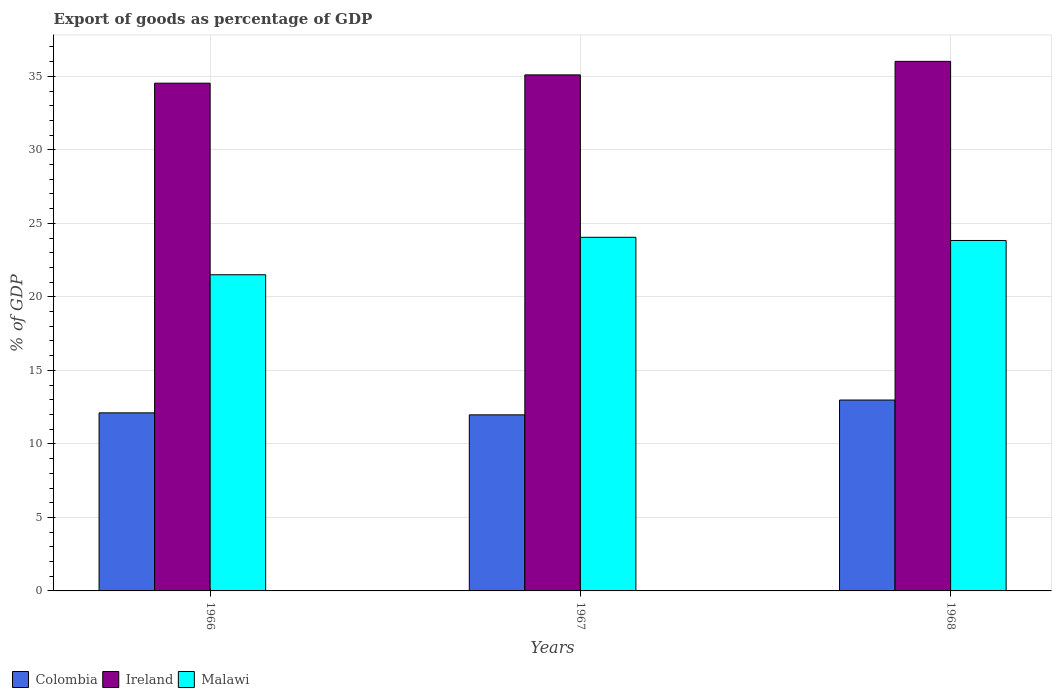How many groups of bars are there?
Offer a very short reply. 3. What is the label of the 1st group of bars from the left?
Give a very brief answer. 1966. In how many cases, is the number of bars for a given year not equal to the number of legend labels?
Offer a very short reply. 0. What is the export of goods as percentage of GDP in Ireland in 1967?
Your response must be concise. 35.1. Across all years, what is the maximum export of goods as percentage of GDP in Colombia?
Make the answer very short. 12.98. Across all years, what is the minimum export of goods as percentage of GDP in Colombia?
Give a very brief answer. 11.98. In which year was the export of goods as percentage of GDP in Malawi maximum?
Give a very brief answer. 1967. In which year was the export of goods as percentage of GDP in Colombia minimum?
Give a very brief answer. 1967. What is the total export of goods as percentage of GDP in Colombia in the graph?
Your answer should be very brief. 37.07. What is the difference between the export of goods as percentage of GDP in Ireland in 1966 and that in 1967?
Your answer should be compact. -0.57. What is the difference between the export of goods as percentage of GDP in Ireland in 1966 and the export of goods as percentage of GDP in Malawi in 1967?
Provide a succinct answer. 10.48. What is the average export of goods as percentage of GDP in Colombia per year?
Your answer should be very brief. 12.36. In the year 1968, what is the difference between the export of goods as percentage of GDP in Malawi and export of goods as percentage of GDP in Colombia?
Your answer should be compact. 10.85. What is the ratio of the export of goods as percentage of GDP in Colombia in 1967 to that in 1968?
Your answer should be compact. 0.92. What is the difference between the highest and the second highest export of goods as percentage of GDP in Colombia?
Your answer should be very brief. 0.87. What is the difference between the highest and the lowest export of goods as percentage of GDP in Colombia?
Offer a terse response. 1.01. In how many years, is the export of goods as percentage of GDP in Ireland greater than the average export of goods as percentage of GDP in Ireland taken over all years?
Make the answer very short. 1. What does the 2nd bar from the left in 1968 represents?
Offer a terse response. Ireland. What does the 1st bar from the right in 1967 represents?
Your answer should be very brief. Malawi. Are all the bars in the graph horizontal?
Provide a succinct answer. No. What is the difference between two consecutive major ticks on the Y-axis?
Your answer should be compact. 5. Does the graph contain grids?
Your response must be concise. Yes. What is the title of the graph?
Your answer should be compact. Export of goods as percentage of GDP. Does "Panama" appear as one of the legend labels in the graph?
Offer a terse response. No. What is the label or title of the Y-axis?
Give a very brief answer. % of GDP. What is the % of GDP in Colombia in 1966?
Make the answer very short. 12.11. What is the % of GDP in Ireland in 1966?
Offer a very short reply. 34.54. What is the % of GDP in Malawi in 1966?
Give a very brief answer. 21.51. What is the % of GDP of Colombia in 1967?
Your answer should be very brief. 11.98. What is the % of GDP of Ireland in 1967?
Your response must be concise. 35.1. What is the % of GDP of Malawi in 1967?
Keep it short and to the point. 24.05. What is the % of GDP of Colombia in 1968?
Your response must be concise. 12.98. What is the % of GDP of Ireland in 1968?
Your answer should be very brief. 36.02. What is the % of GDP of Malawi in 1968?
Your answer should be compact. 23.84. Across all years, what is the maximum % of GDP in Colombia?
Provide a succinct answer. 12.98. Across all years, what is the maximum % of GDP in Ireland?
Make the answer very short. 36.02. Across all years, what is the maximum % of GDP in Malawi?
Offer a terse response. 24.05. Across all years, what is the minimum % of GDP of Colombia?
Provide a succinct answer. 11.98. Across all years, what is the minimum % of GDP of Ireland?
Provide a short and direct response. 34.54. Across all years, what is the minimum % of GDP of Malawi?
Give a very brief answer. 21.51. What is the total % of GDP of Colombia in the graph?
Your answer should be compact. 37.07. What is the total % of GDP of Ireland in the graph?
Offer a terse response. 105.66. What is the total % of GDP in Malawi in the graph?
Your answer should be compact. 69.4. What is the difference between the % of GDP of Colombia in 1966 and that in 1967?
Your response must be concise. 0.14. What is the difference between the % of GDP of Ireland in 1966 and that in 1967?
Keep it short and to the point. -0.57. What is the difference between the % of GDP in Malawi in 1966 and that in 1967?
Your response must be concise. -2.55. What is the difference between the % of GDP of Colombia in 1966 and that in 1968?
Ensure brevity in your answer.  -0.87. What is the difference between the % of GDP in Ireland in 1966 and that in 1968?
Your response must be concise. -1.49. What is the difference between the % of GDP of Malawi in 1966 and that in 1968?
Provide a succinct answer. -2.33. What is the difference between the % of GDP of Colombia in 1967 and that in 1968?
Your response must be concise. -1.01. What is the difference between the % of GDP of Ireland in 1967 and that in 1968?
Keep it short and to the point. -0.92. What is the difference between the % of GDP in Malawi in 1967 and that in 1968?
Your response must be concise. 0.22. What is the difference between the % of GDP of Colombia in 1966 and the % of GDP of Ireland in 1967?
Make the answer very short. -22.99. What is the difference between the % of GDP in Colombia in 1966 and the % of GDP in Malawi in 1967?
Your answer should be compact. -11.94. What is the difference between the % of GDP in Ireland in 1966 and the % of GDP in Malawi in 1967?
Keep it short and to the point. 10.48. What is the difference between the % of GDP in Colombia in 1966 and the % of GDP in Ireland in 1968?
Offer a very short reply. -23.91. What is the difference between the % of GDP in Colombia in 1966 and the % of GDP in Malawi in 1968?
Your answer should be compact. -11.72. What is the difference between the % of GDP in Ireland in 1966 and the % of GDP in Malawi in 1968?
Your response must be concise. 10.7. What is the difference between the % of GDP of Colombia in 1967 and the % of GDP of Ireland in 1968?
Make the answer very short. -24.05. What is the difference between the % of GDP of Colombia in 1967 and the % of GDP of Malawi in 1968?
Make the answer very short. -11.86. What is the difference between the % of GDP in Ireland in 1967 and the % of GDP in Malawi in 1968?
Give a very brief answer. 11.26. What is the average % of GDP in Colombia per year?
Keep it short and to the point. 12.36. What is the average % of GDP in Ireland per year?
Your response must be concise. 35.22. What is the average % of GDP of Malawi per year?
Ensure brevity in your answer.  23.13. In the year 1966, what is the difference between the % of GDP of Colombia and % of GDP of Ireland?
Provide a succinct answer. -22.42. In the year 1966, what is the difference between the % of GDP of Colombia and % of GDP of Malawi?
Provide a short and direct response. -9.39. In the year 1966, what is the difference between the % of GDP in Ireland and % of GDP in Malawi?
Your answer should be very brief. 13.03. In the year 1967, what is the difference between the % of GDP in Colombia and % of GDP in Ireland?
Your response must be concise. -23.13. In the year 1967, what is the difference between the % of GDP in Colombia and % of GDP in Malawi?
Your answer should be compact. -12.08. In the year 1967, what is the difference between the % of GDP of Ireland and % of GDP of Malawi?
Your answer should be very brief. 11.05. In the year 1968, what is the difference between the % of GDP of Colombia and % of GDP of Ireland?
Offer a very short reply. -23.04. In the year 1968, what is the difference between the % of GDP in Colombia and % of GDP in Malawi?
Keep it short and to the point. -10.85. In the year 1968, what is the difference between the % of GDP of Ireland and % of GDP of Malawi?
Your answer should be very brief. 12.18. What is the ratio of the % of GDP in Colombia in 1966 to that in 1967?
Offer a terse response. 1.01. What is the ratio of the % of GDP of Ireland in 1966 to that in 1967?
Your answer should be very brief. 0.98. What is the ratio of the % of GDP of Malawi in 1966 to that in 1967?
Offer a terse response. 0.89. What is the ratio of the % of GDP of Colombia in 1966 to that in 1968?
Offer a terse response. 0.93. What is the ratio of the % of GDP of Ireland in 1966 to that in 1968?
Provide a succinct answer. 0.96. What is the ratio of the % of GDP of Malawi in 1966 to that in 1968?
Offer a very short reply. 0.9. What is the ratio of the % of GDP of Colombia in 1967 to that in 1968?
Provide a short and direct response. 0.92. What is the ratio of the % of GDP in Ireland in 1967 to that in 1968?
Give a very brief answer. 0.97. What is the ratio of the % of GDP in Malawi in 1967 to that in 1968?
Provide a succinct answer. 1.01. What is the difference between the highest and the second highest % of GDP in Colombia?
Provide a succinct answer. 0.87. What is the difference between the highest and the second highest % of GDP of Malawi?
Your answer should be very brief. 0.22. What is the difference between the highest and the lowest % of GDP in Ireland?
Offer a very short reply. 1.49. What is the difference between the highest and the lowest % of GDP in Malawi?
Your answer should be compact. 2.55. 